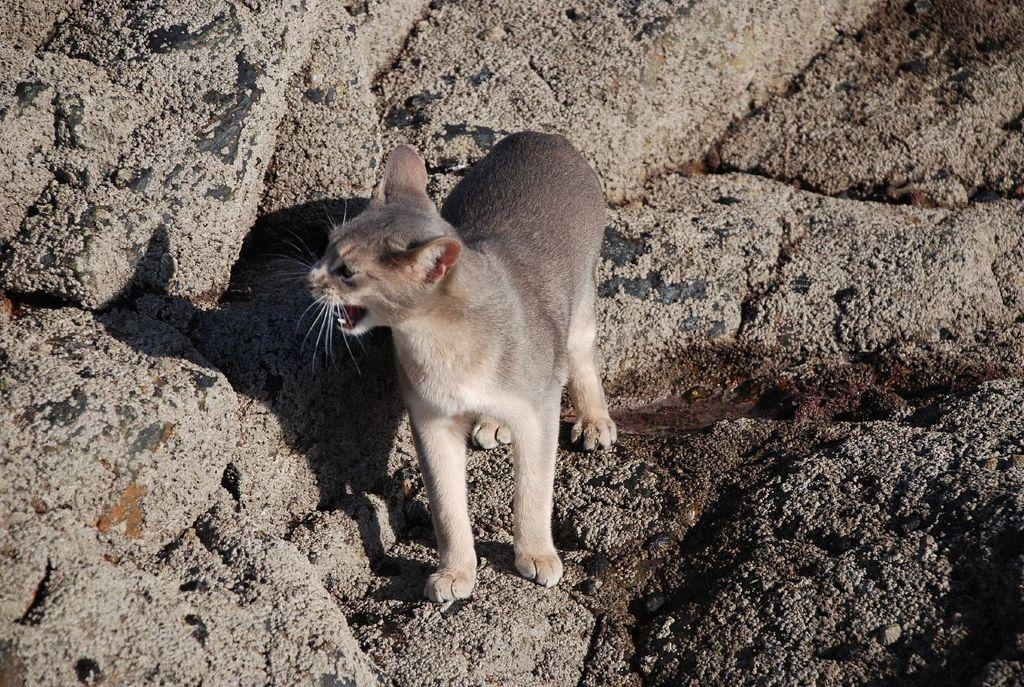What animal is present in the image? There is a cat in the image. Where is the cat located? The cat is on a rock. How are the cat and rock positioned in the image? The cat and rock are in the center of the image. What type of crack is visible on the cat's fur in the image? There is no crack visible on the cat's fur in the image. 